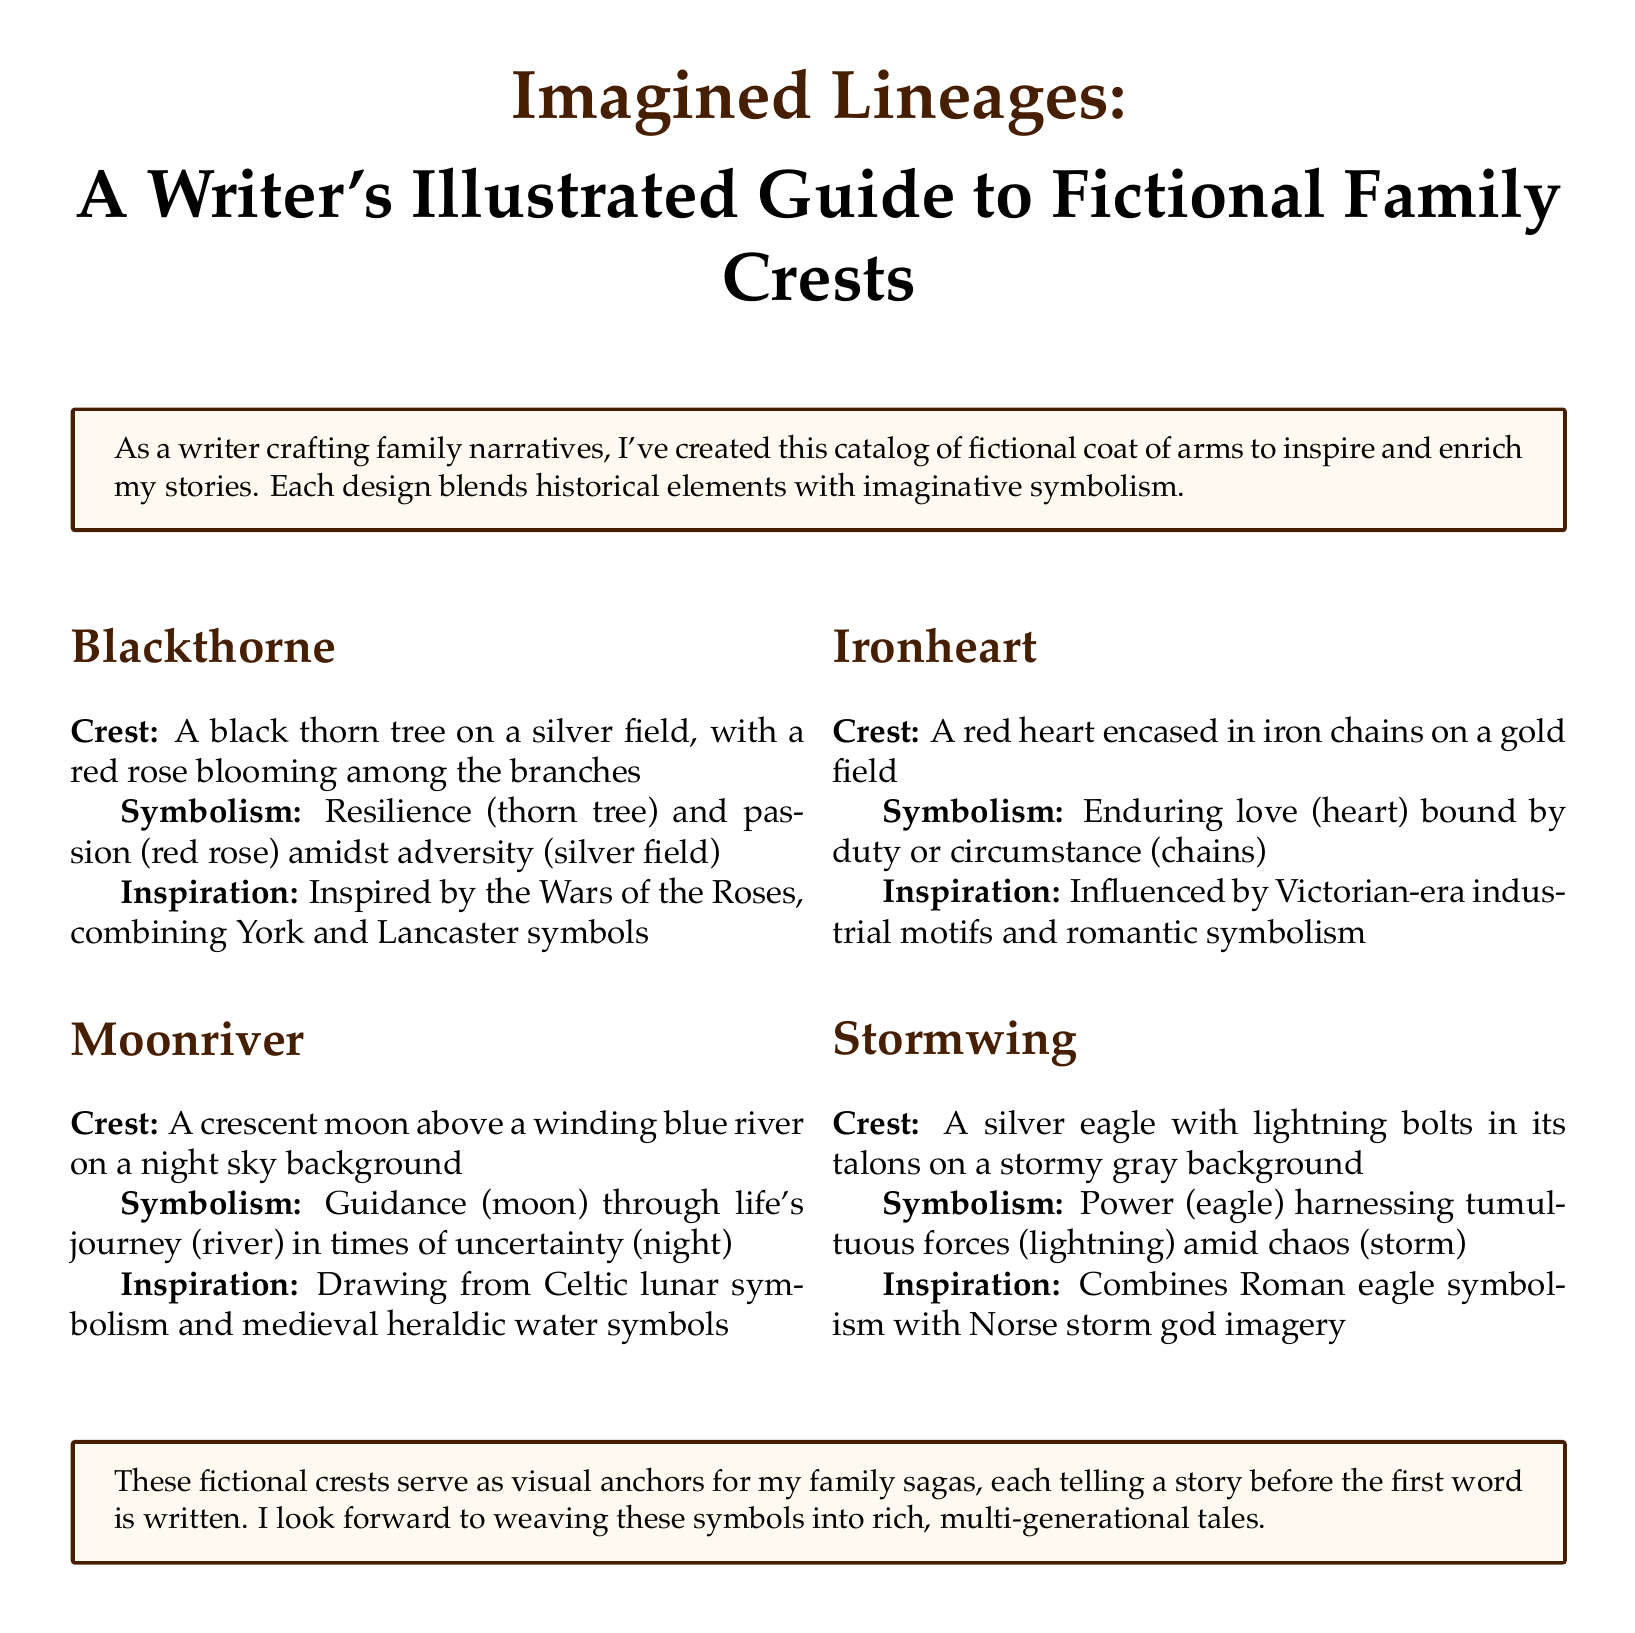What is the name of the first family crest? The first family crest listed in the document is "Blackthorne."
Answer: Blackthorne What is depicted on the Ironheart crest? The Ironheart crest features a red heart encased in iron chains on a gold field.
Answer: A red heart encased in iron chains What is the symbolic meaning of the Moonriver crest? The Moonriver crest symbolizes guidance through life's journey in times of uncertainty.
Answer: Guidance through life's journey What historical inspiration influenced the Blackthorne design? The Blackthorne design is inspired by the Wars of the Roses, combining York and Lancaster symbols.
Answer: Wars of the Roses How many family crests are illustrated in the document? There are four family crests illustrated in the document.
Answer: Four What color is the background of the Stormwing crest? The background of the Stormwing crest is stormy gray.
Answer: Stormy gray What flower blooms among the branches of the Blackthorne crest? A red rose blooms among the branches of the Blackthorne crest.
Answer: Red rose What animal is featured in the Stormwing crest? The Stormwing crest features a silver eagle.
Answer: Silver eagle What theme connects the crests in terms of their symbolism? The crests all convey themes of resilience, guidance, love, and power amidst adversity.
Answer: Resilience, guidance, love, and power 